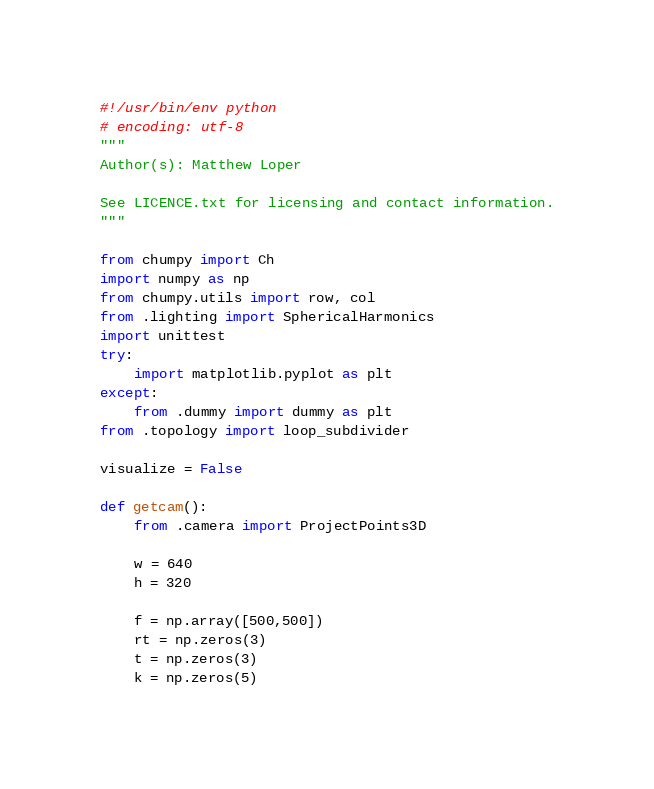Convert code to text. <code><loc_0><loc_0><loc_500><loc_500><_Python_>#!/usr/bin/env python
# encoding: utf-8
"""
Author(s): Matthew Loper

See LICENCE.txt for licensing and contact information.
"""

from chumpy import Ch
import numpy as np
from chumpy.utils import row, col
from .lighting import SphericalHarmonics
import unittest
try:
    import matplotlib.pyplot as plt
except:
    from .dummy import dummy as plt
from .topology import loop_subdivider

visualize = False

def getcam():
    from .camera import ProjectPoints3D

    w = 640
    h = 320

    f = np.array([500,500])
    rt = np.zeros(3)
    t = np.zeros(3)
    k = np.zeros(5)</code> 